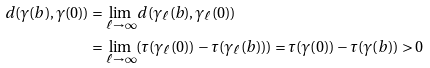Convert formula to latex. <formula><loc_0><loc_0><loc_500><loc_500>d ( \gamma ( b ) , \gamma ( 0 ) ) & = \lim _ { \ell \to \infty } d ( \gamma _ { \ell } ( b ) , \gamma _ { \ell } ( 0 ) ) \\ & = \lim _ { \ell \to \infty } ( \tau ( \gamma _ { \ell } ( 0 ) ) - \tau ( \gamma _ { \ell } ( b ) ) ) = \tau ( \gamma ( 0 ) ) - \tau ( \gamma ( b ) ) > 0</formula> 